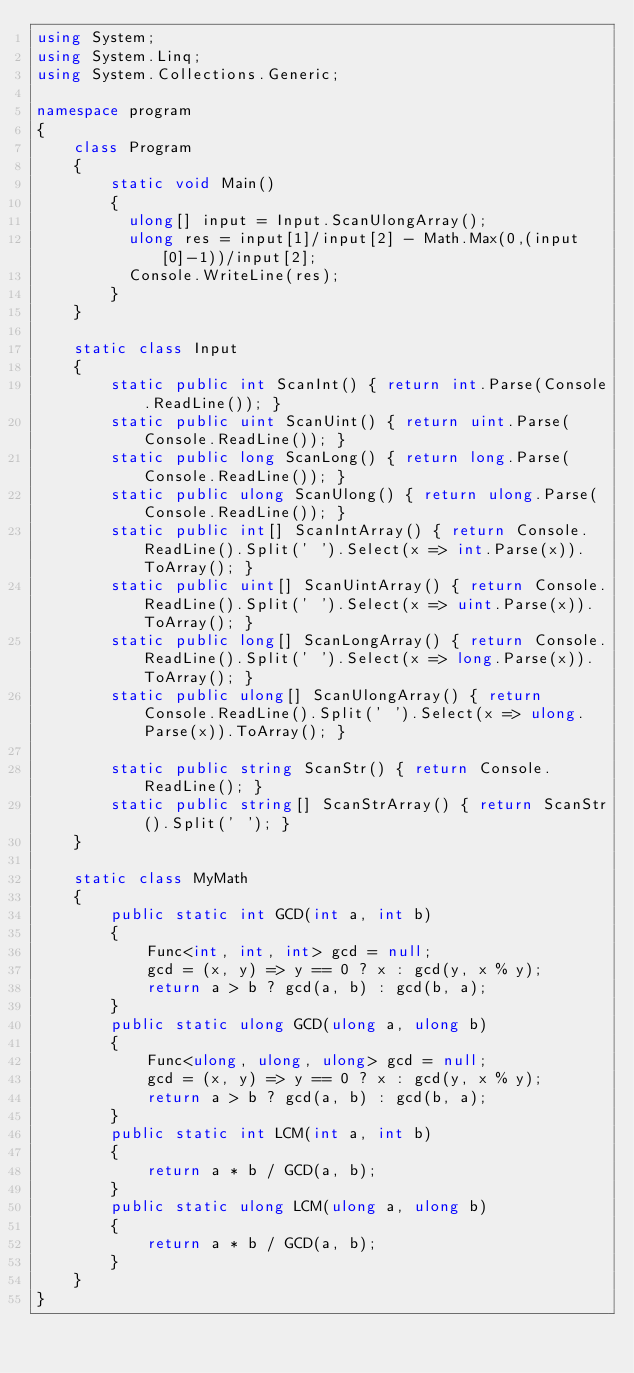<code> <loc_0><loc_0><loc_500><loc_500><_C#_>using System;
using System.Linq;
using System.Collections.Generic;

namespace program
{
    class Program
    {
        static void Main()
        {
          ulong[] input = Input.ScanUlongArray();
          ulong res = input[1]/input[2] - Math.Max(0,(input[0]-1))/input[2];
          Console.WriteLine(res);
        }
    }

    static class Input
    {
        static public int ScanInt() { return int.Parse(Console.ReadLine()); }
        static public uint ScanUint() { return uint.Parse(Console.ReadLine()); }
        static public long ScanLong() { return long.Parse(Console.ReadLine()); }
        static public ulong ScanUlong() { return ulong.Parse(Console.ReadLine()); }
        static public int[] ScanIntArray() { return Console.ReadLine().Split(' ').Select(x => int.Parse(x)).ToArray(); }
        static public uint[] ScanUintArray() { return Console.ReadLine().Split(' ').Select(x => uint.Parse(x)).ToArray(); }
        static public long[] ScanLongArray() { return Console.ReadLine().Split(' ').Select(x => long.Parse(x)).ToArray(); }
        static public ulong[] ScanUlongArray() { return Console.ReadLine().Split(' ').Select(x => ulong.Parse(x)).ToArray(); }

        static public string ScanStr() { return Console.ReadLine(); }
        static public string[] ScanStrArray() { return ScanStr().Split(' '); }
    }

    static class MyMath
    {
        public static int GCD(int a, int b)
        {
            Func<int, int, int> gcd = null;
            gcd = (x, y) => y == 0 ? x : gcd(y, x % y);
            return a > b ? gcd(a, b) : gcd(b, a);
        }
        public static ulong GCD(ulong a, ulong b)
        {
            Func<ulong, ulong, ulong> gcd = null;
            gcd = (x, y) => y == 0 ? x : gcd(y, x % y);
            return a > b ? gcd(a, b) : gcd(b, a);
        }
        public static int LCM(int a, int b)
        {
            return a * b / GCD(a, b);
        }
        public static ulong LCM(ulong a, ulong b)
        {
            return a * b / GCD(a, b);
        }
    }
}
</code> 